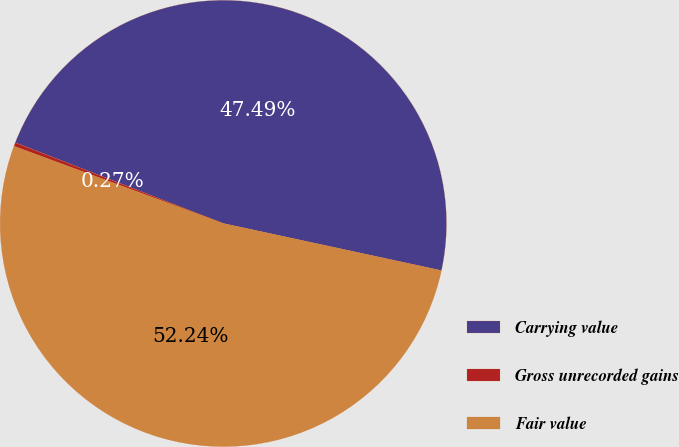Convert chart. <chart><loc_0><loc_0><loc_500><loc_500><pie_chart><fcel>Carrying value<fcel>Gross unrecorded gains<fcel>Fair value<nl><fcel>47.49%<fcel>0.27%<fcel>52.24%<nl></chart> 